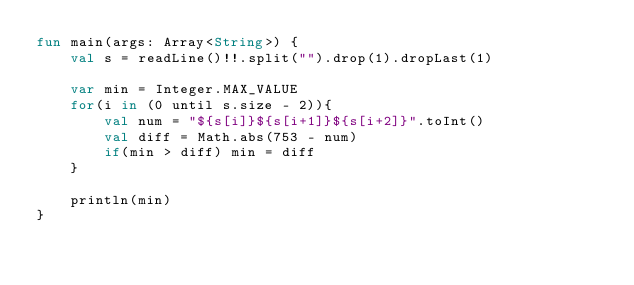<code> <loc_0><loc_0><loc_500><loc_500><_Kotlin_>fun main(args: Array<String>) {
    val s = readLine()!!.split("").drop(1).dropLast(1)

    var min = Integer.MAX_VALUE
    for(i in (0 until s.size - 2)){
        val num = "${s[i]}${s[i+1]}${s[i+2]}".toInt()
        val diff = Math.abs(753 - num)
        if(min > diff) min = diff
    }

    println(min)
}</code> 